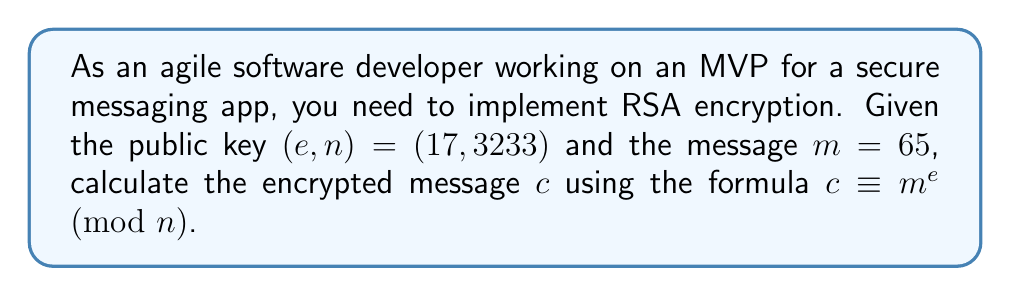Give your solution to this math problem. To calculate the modular exponentiation for RSA encryption, we need to use the formula:

$c \equiv m^e \pmod{n}$

Given:
$m = 65$
$e = 17$
$n = 3233$

We need to calculate $65^{17} \pmod{3233}$. This is a large number, so we'll use the square-and-multiply algorithm to efficiently compute it:

1) Convert the exponent (17) to binary: $17_{10} = 10001_2$

2) Initialize: $result = 1$

3) For each bit in the binary exponent (from left to right):
   a) Square the result: $result = result^2 \pmod{3233}$
   b) If the bit is 1, multiply by $m$: $result = result \cdot 65 \pmod{3233}$

Step-by-step calculation:

1) $1^2 \cdot 65 \equiv 65 \pmod{3233}$
2) $65^2 \equiv 4225 \equiv 992 \pmod{3233}$
3) $992^2 \equiv 984064 \equiv 2893 \pmod{3233}$
4) $2893^2 \equiv 8369449 \equiv 2513 \pmod{3233}$
5) $2513^2 \cdot 65 \equiv 6315169 \cdot 65 \equiv 2509 \cdot 65 \equiv 163085 \equiv 2132 \pmod{3233}$

Therefore, the encrypted message $c$ is 2132.
Answer: $2132$ 